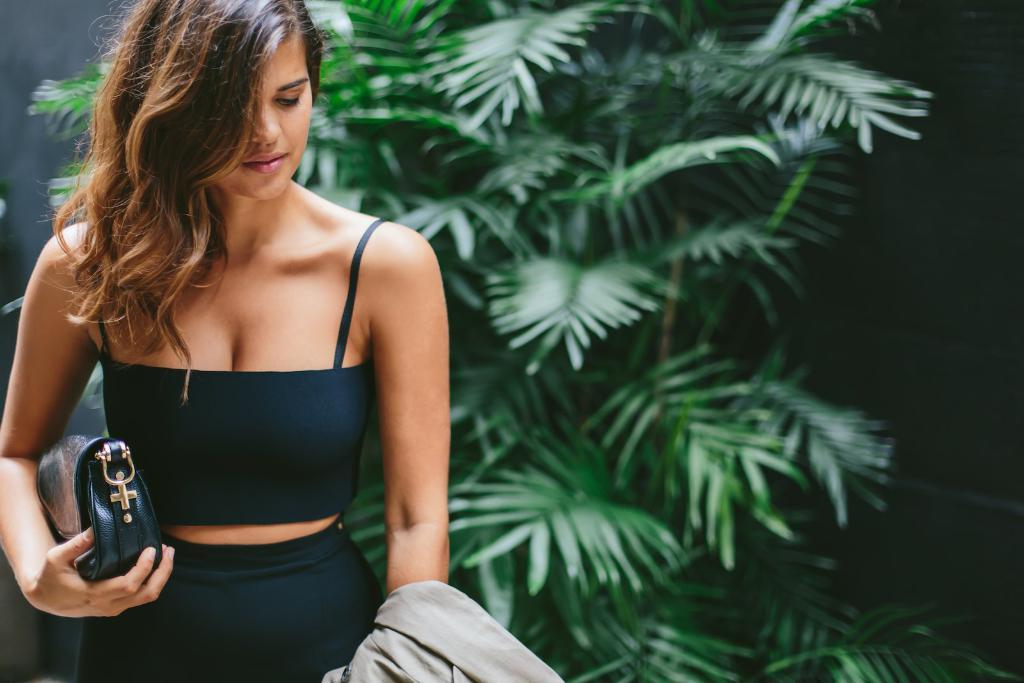Who is present in the image? There is a woman in the image. What is the woman doing in the image? The woman is standing behind a plant. What items is the woman holding in the image? The woman is holding a handbag and a jacket. What type of leaf is the woman using to cover the ice in the image? There is no leaf or ice present in the image. Is the woman in the image being held in a prison? There is no indication of a prison or any confinement in the image; the woman is standing behind a plant. 